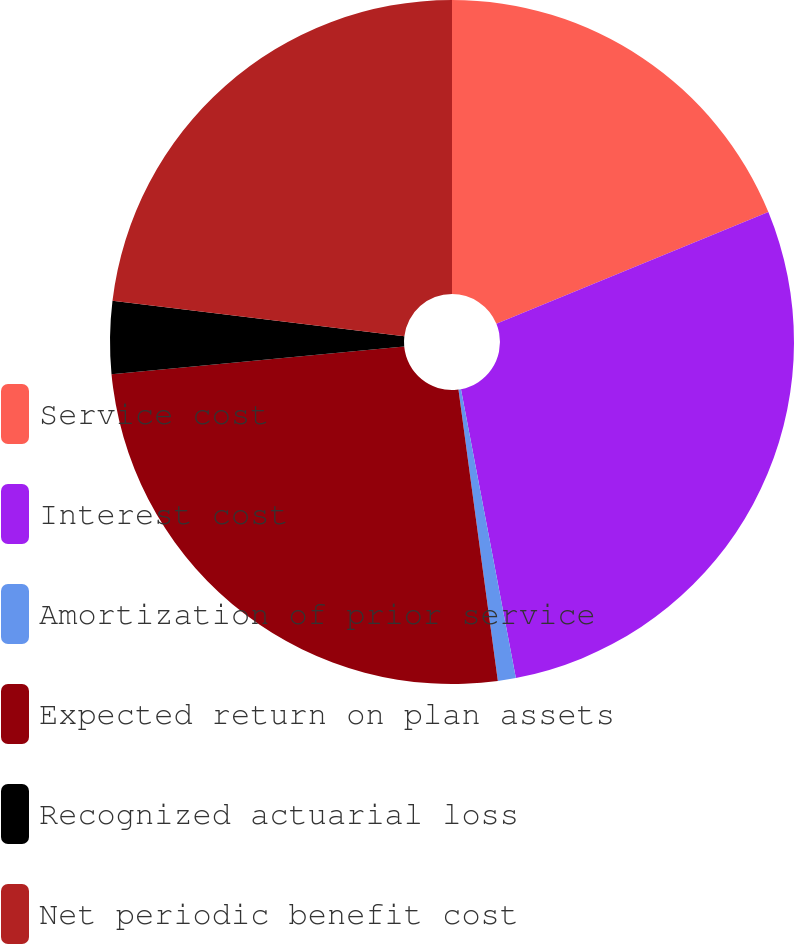Convert chart. <chart><loc_0><loc_0><loc_500><loc_500><pie_chart><fcel>Service cost<fcel>Interest cost<fcel>Amortization of prior service<fcel>Expected return on plan assets<fcel>Recognized actuarial loss<fcel>Net periodic benefit cost<nl><fcel>18.8%<fcel>28.21%<fcel>0.85%<fcel>25.64%<fcel>3.42%<fcel>23.08%<nl></chart> 